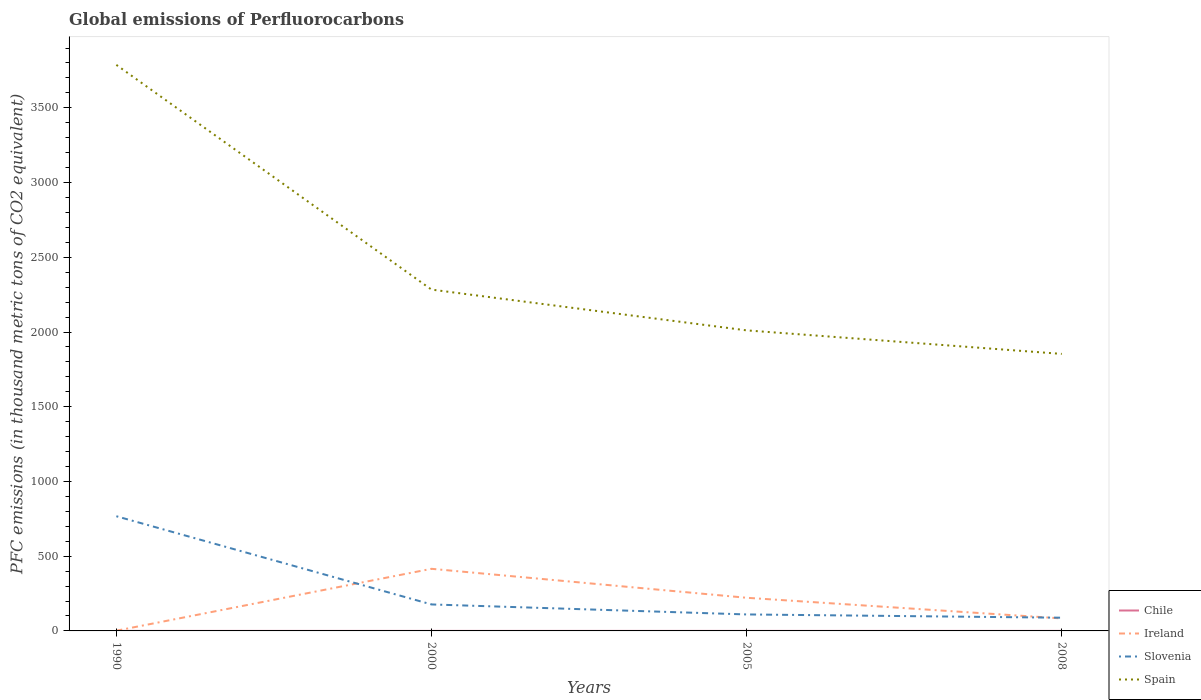How many different coloured lines are there?
Provide a succinct answer. 4. Across all years, what is the maximum global emissions of Perfluorocarbons in Ireland?
Ensure brevity in your answer.  1.4. What is the total global emissions of Perfluorocarbons in Slovenia in the graph?
Offer a terse response. 679. What is the difference between the highest and the second highest global emissions of Perfluorocarbons in Ireland?
Offer a very short reply. 414.2. What is the difference between the highest and the lowest global emissions of Perfluorocarbons in Ireland?
Provide a short and direct response. 2. Is the global emissions of Perfluorocarbons in Ireland strictly greater than the global emissions of Perfluorocarbons in Chile over the years?
Ensure brevity in your answer.  No. Are the values on the major ticks of Y-axis written in scientific E-notation?
Ensure brevity in your answer.  No. Does the graph contain any zero values?
Provide a succinct answer. No. Does the graph contain grids?
Provide a succinct answer. No. Where does the legend appear in the graph?
Your answer should be compact. Bottom right. What is the title of the graph?
Offer a very short reply. Global emissions of Perfluorocarbons. What is the label or title of the Y-axis?
Ensure brevity in your answer.  PFC emissions (in thousand metric tons of CO2 equivalent). What is the PFC emissions (in thousand metric tons of CO2 equivalent) in Slovenia in 1990?
Your answer should be compact. 767.4. What is the PFC emissions (in thousand metric tons of CO2 equivalent) of Spain in 1990?
Provide a short and direct response. 3787.4. What is the PFC emissions (in thousand metric tons of CO2 equivalent) in Chile in 2000?
Offer a terse response. 0.2. What is the PFC emissions (in thousand metric tons of CO2 equivalent) in Ireland in 2000?
Your response must be concise. 415.6. What is the PFC emissions (in thousand metric tons of CO2 equivalent) of Slovenia in 2000?
Make the answer very short. 177.2. What is the PFC emissions (in thousand metric tons of CO2 equivalent) of Spain in 2000?
Ensure brevity in your answer.  2283.8. What is the PFC emissions (in thousand metric tons of CO2 equivalent) in Ireland in 2005?
Offer a terse response. 221.8. What is the PFC emissions (in thousand metric tons of CO2 equivalent) in Slovenia in 2005?
Keep it short and to the point. 110.3. What is the PFC emissions (in thousand metric tons of CO2 equivalent) in Spain in 2005?
Your answer should be very brief. 2011. What is the PFC emissions (in thousand metric tons of CO2 equivalent) of Chile in 2008?
Provide a succinct answer. 0.2. What is the PFC emissions (in thousand metric tons of CO2 equivalent) in Ireland in 2008?
Your response must be concise. 83.6. What is the PFC emissions (in thousand metric tons of CO2 equivalent) in Slovenia in 2008?
Make the answer very short. 88.4. What is the PFC emissions (in thousand metric tons of CO2 equivalent) in Spain in 2008?
Your answer should be compact. 1853.5. Across all years, what is the maximum PFC emissions (in thousand metric tons of CO2 equivalent) of Ireland?
Make the answer very short. 415.6. Across all years, what is the maximum PFC emissions (in thousand metric tons of CO2 equivalent) of Slovenia?
Your answer should be very brief. 767.4. Across all years, what is the maximum PFC emissions (in thousand metric tons of CO2 equivalent) in Spain?
Provide a short and direct response. 3787.4. Across all years, what is the minimum PFC emissions (in thousand metric tons of CO2 equivalent) of Chile?
Your answer should be very brief. 0.2. Across all years, what is the minimum PFC emissions (in thousand metric tons of CO2 equivalent) in Slovenia?
Make the answer very short. 88.4. Across all years, what is the minimum PFC emissions (in thousand metric tons of CO2 equivalent) in Spain?
Offer a very short reply. 1853.5. What is the total PFC emissions (in thousand metric tons of CO2 equivalent) of Ireland in the graph?
Ensure brevity in your answer.  722.4. What is the total PFC emissions (in thousand metric tons of CO2 equivalent) of Slovenia in the graph?
Make the answer very short. 1143.3. What is the total PFC emissions (in thousand metric tons of CO2 equivalent) in Spain in the graph?
Make the answer very short. 9935.7. What is the difference between the PFC emissions (in thousand metric tons of CO2 equivalent) of Chile in 1990 and that in 2000?
Ensure brevity in your answer.  0. What is the difference between the PFC emissions (in thousand metric tons of CO2 equivalent) in Ireland in 1990 and that in 2000?
Offer a very short reply. -414.2. What is the difference between the PFC emissions (in thousand metric tons of CO2 equivalent) in Slovenia in 1990 and that in 2000?
Your answer should be very brief. 590.2. What is the difference between the PFC emissions (in thousand metric tons of CO2 equivalent) of Spain in 1990 and that in 2000?
Offer a terse response. 1503.6. What is the difference between the PFC emissions (in thousand metric tons of CO2 equivalent) of Ireland in 1990 and that in 2005?
Give a very brief answer. -220.4. What is the difference between the PFC emissions (in thousand metric tons of CO2 equivalent) of Slovenia in 1990 and that in 2005?
Make the answer very short. 657.1. What is the difference between the PFC emissions (in thousand metric tons of CO2 equivalent) of Spain in 1990 and that in 2005?
Offer a terse response. 1776.4. What is the difference between the PFC emissions (in thousand metric tons of CO2 equivalent) in Chile in 1990 and that in 2008?
Give a very brief answer. 0. What is the difference between the PFC emissions (in thousand metric tons of CO2 equivalent) of Ireland in 1990 and that in 2008?
Ensure brevity in your answer.  -82.2. What is the difference between the PFC emissions (in thousand metric tons of CO2 equivalent) of Slovenia in 1990 and that in 2008?
Keep it short and to the point. 679. What is the difference between the PFC emissions (in thousand metric tons of CO2 equivalent) of Spain in 1990 and that in 2008?
Your answer should be very brief. 1933.9. What is the difference between the PFC emissions (in thousand metric tons of CO2 equivalent) of Ireland in 2000 and that in 2005?
Offer a very short reply. 193.8. What is the difference between the PFC emissions (in thousand metric tons of CO2 equivalent) of Slovenia in 2000 and that in 2005?
Offer a very short reply. 66.9. What is the difference between the PFC emissions (in thousand metric tons of CO2 equivalent) in Spain in 2000 and that in 2005?
Provide a short and direct response. 272.8. What is the difference between the PFC emissions (in thousand metric tons of CO2 equivalent) in Ireland in 2000 and that in 2008?
Offer a very short reply. 332. What is the difference between the PFC emissions (in thousand metric tons of CO2 equivalent) of Slovenia in 2000 and that in 2008?
Provide a succinct answer. 88.8. What is the difference between the PFC emissions (in thousand metric tons of CO2 equivalent) of Spain in 2000 and that in 2008?
Your answer should be very brief. 430.3. What is the difference between the PFC emissions (in thousand metric tons of CO2 equivalent) in Chile in 2005 and that in 2008?
Keep it short and to the point. 0. What is the difference between the PFC emissions (in thousand metric tons of CO2 equivalent) in Ireland in 2005 and that in 2008?
Keep it short and to the point. 138.2. What is the difference between the PFC emissions (in thousand metric tons of CO2 equivalent) of Slovenia in 2005 and that in 2008?
Keep it short and to the point. 21.9. What is the difference between the PFC emissions (in thousand metric tons of CO2 equivalent) in Spain in 2005 and that in 2008?
Offer a very short reply. 157.5. What is the difference between the PFC emissions (in thousand metric tons of CO2 equivalent) of Chile in 1990 and the PFC emissions (in thousand metric tons of CO2 equivalent) of Ireland in 2000?
Make the answer very short. -415.4. What is the difference between the PFC emissions (in thousand metric tons of CO2 equivalent) in Chile in 1990 and the PFC emissions (in thousand metric tons of CO2 equivalent) in Slovenia in 2000?
Provide a short and direct response. -177. What is the difference between the PFC emissions (in thousand metric tons of CO2 equivalent) in Chile in 1990 and the PFC emissions (in thousand metric tons of CO2 equivalent) in Spain in 2000?
Keep it short and to the point. -2283.6. What is the difference between the PFC emissions (in thousand metric tons of CO2 equivalent) of Ireland in 1990 and the PFC emissions (in thousand metric tons of CO2 equivalent) of Slovenia in 2000?
Offer a very short reply. -175.8. What is the difference between the PFC emissions (in thousand metric tons of CO2 equivalent) in Ireland in 1990 and the PFC emissions (in thousand metric tons of CO2 equivalent) in Spain in 2000?
Keep it short and to the point. -2282.4. What is the difference between the PFC emissions (in thousand metric tons of CO2 equivalent) in Slovenia in 1990 and the PFC emissions (in thousand metric tons of CO2 equivalent) in Spain in 2000?
Provide a succinct answer. -1516.4. What is the difference between the PFC emissions (in thousand metric tons of CO2 equivalent) in Chile in 1990 and the PFC emissions (in thousand metric tons of CO2 equivalent) in Ireland in 2005?
Provide a succinct answer. -221.6. What is the difference between the PFC emissions (in thousand metric tons of CO2 equivalent) of Chile in 1990 and the PFC emissions (in thousand metric tons of CO2 equivalent) of Slovenia in 2005?
Ensure brevity in your answer.  -110.1. What is the difference between the PFC emissions (in thousand metric tons of CO2 equivalent) in Chile in 1990 and the PFC emissions (in thousand metric tons of CO2 equivalent) in Spain in 2005?
Give a very brief answer. -2010.8. What is the difference between the PFC emissions (in thousand metric tons of CO2 equivalent) of Ireland in 1990 and the PFC emissions (in thousand metric tons of CO2 equivalent) of Slovenia in 2005?
Make the answer very short. -108.9. What is the difference between the PFC emissions (in thousand metric tons of CO2 equivalent) in Ireland in 1990 and the PFC emissions (in thousand metric tons of CO2 equivalent) in Spain in 2005?
Keep it short and to the point. -2009.6. What is the difference between the PFC emissions (in thousand metric tons of CO2 equivalent) of Slovenia in 1990 and the PFC emissions (in thousand metric tons of CO2 equivalent) of Spain in 2005?
Your answer should be compact. -1243.6. What is the difference between the PFC emissions (in thousand metric tons of CO2 equivalent) in Chile in 1990 and the PFC emissions (in thousand metric tons of CO2 equivalent) in Ireland in 2008?
Make the answer very short. -83.4. What is the difference between the PFC emissions (in thousand metric tons of CO2 equivalent) of Chile in 1990 and the PFC emissions (in thousand metric tons of CO2 equivalent) of Slovenia in 2008?
Offer a terse response. -88.2. What is the difference between the PFC emissions (in thousand metric tons of CO2 equivalent) of Chile in 1990 and the PFC emissions (in thousand metric tons of CO2 equivalent) of Spain in 2008?
Your answer should be very brief. -1853.3. What is the difference between the PFC emissions (in thousand metric tons of CO2 equivalent) in Ireland in 1990 and the PFC emissions (in thousand metric tons of CO2 equivalent) in Slovenia in 2008?
Your answer should be compact. -87. What is the difference between the PFC emissions (in thousand metric tons of CO2 equivalent) of Ireland in 1990 and the PFC emissions (in thousand metric tons of CO2 equivalent) of Spain in 2008?
Ensure brevity in your answer.  -1852.1. What is the difference between the PFC emissions (in thousand metric tons of CO2 equivalent) of Slovenia in 1990 and the PFC emissions (in thousand metric tons of CO2 equivalent) of Spain in 2008?
Keep it short and to the point. -1086.1. What is the difference between the PFC emissions (in thousand metric tons of CO2 equivalent) of Chile in 2000 and the PFC emissions (in thousand metric tons of CO2 equivalent) of Ireland in 2005?
Your answer should be very brief. -221.6. What is the difference between the PFC emissions (in thousand metric tons of CO2 equivalent) of Chile in 2000 and the PFC emissions (in thousand metric tons of CO2 equivalent) of Slovenia in 2005?
Provide a short and direct response. -110.1. What is the difference between the PFC emissions (in thousand metric tons of CO2 equivalent) in Chile in 2000 and the PFC emissions (in thousand metric tons of CO2 equivalent) in Spain in 2005?
Your answer should be very brief. -2010.8. What is the difference between the PFC emissions (in thousand metric tons of CO2 equivalent) in Ireland in 2000 and the PFC emissions (in thousand metric tons of CO2 equivalent) in Slovenia in 2005?
Offer a very short reply. 305.3. What is the difference between the PFC emissions (in thousand metric tons of CO2 equivalent) of Ireland in 2000 and the PFC emissions (in thousand metric tons of CO2 equivalent) of Spain in 2005?
Make the answer very short. -1595.4. What is the difference between the PFC emissions (in thousand metric tons of CO2 equivalent) of Slovenia in 2000 and the PFC emissions (in thousand metric tons of CO2 equivalent) of Spain in 2005?
Your response must be concise. -1833.8. What is the difference between the PFC emissions (in thousand metric tons of CO2 equivalent) of Chile in 2000 and the PFC emissions (in thousand metric tons of CO2 equivalent) of Ireland in 2008?
Your response must be concise. -83.4. What is the difference between the PFC emissions (in thousand metric tons of CO2 equivalent) of Chile in 2000 and the PFC emissions (in thousand metric tons of CO2 equivalent) of Slovenia in 2008?
Your response must be concise. -88.2. What is the difference between the PFC emissions (in thousand metric tons of CO2 equivalent) in Chile in 2000 and the PFC emissions (in thousand metric tons of CO2 equivalent) in Spain in 2008?
Ensure brevity in your answer.  -1853.3. What is the difference between the PFC emissions (in thousand metric tons of CO2 equivalent) of Ireland in 2000 and the PFC emissions (in thousand metric tons of CO2 equivalent) of Slovenia in 2008?
Your answer should be very brief. 327.2. What is the difference between the PFC emissions (in thousand metric tons of CO2 equivalent) in Ireland in 2000 and the PFC emissions (in thousand metric tons of CO2 equivalent) in Spain in 2008?
Keep it short and to the point. -1437.9. What is the difference between the PFC emissions (in thousand metric tons of CO2 equivalent) in Slovenia in 2000 and the PFC emissions (in thousand metric tons of CO2 equivalent) in Spain in 2008?
Offer a terse response. -1676.3. What is the difference between the PFC emissions (in thousand metric tons of CO2 equivalent) of Chile in 2005 and the PFC emissions (in thousand metric tons of CO2 equivalent) of Ireland in 2008?
Your response must be concise. -83.4. What is the difference between the PFC emissions (in thousand metric tons of CO2 equivalent) of Chile in 2005 and the PFC emissions (in thousand metric tons of CO2 equivalent) of Slovenia in 2008?
Provide a succinct answer. -88.2. What is the difference between the PFC emissions (in thousand metric tons of CO2 equivalent) in Chile in 2005 and the PFC emissions (in thousand metric tons of CO2 equivalent) in Spain in 2008?
Make the answer very short. -1853.3. What is the difference between the PFC emissions (in thousand metric tons of CO2 equivalent) of Ireland in 2005 and the PFC emissions (in thousand metric tons of CO2 equivalent) of Slovenia in 2008?
Your response must be concise. 133.4. What is the difference between the PFC emissions (in thousand metric tons of CO2 equivalent) of Ireland in 2005 and the PFC emissions (in thousand metric tons of CO2 equivalent) of Spain in 2008?
Your answer should be compact. -1631.7. What is the difference between the PFC emissions (in thousand metric tons of CO2 equivalent) in Slovenia in 2005 and the PFC emissions (in thousand metric tons of CO2 equivalent) in Spain in 2008?
Provide a short and direct response. -1743.2. What is the average PFC emissions (in thousand metric tons of CO2 equivalent) in Ireland per year?
Make the answer very short. 180.6. What is the average PFC emissions (in thousand metric tons of CO2 equivalent) of Slovenia per year?
Provide a succinct answer. 285.82. What is the average PFC emissions (in thousand metric tons of CO2 equivalent) in Spain per year?
Your answer should be very brief. 2483.93. In the year 1990, what is the difference between the PFC emissions (in thousand metric tons of CO2 equivalent) of Chile and PFC emissions (in thousand metric tons of CO2 equivalent) of Ireland?
Make the answer very short. -1.2. In the year 1990, what is the difference between the PFC emissions (in thousand metric tons of CO2 equivalent) in Chile and PFC emissions (in thousand metric tons of CO2 equivalent) in Slovenia?
Give a very brief answer. -767.2. In the year 1990, what is the difference between the PFC emissions (in thousand metric tons of CO2 equivalent) of Chile and PFC emissions (in thousand metric tons of CO2 equivalent) of Spain?
Provide a short and direct response. -3787.2. In the year 1990, what is the difference between the PFC emissions (in thousand metric tons of CO2 equivalent) in Ireland and PFC emissions (in thousand metric tons of CO2 equivalent) in Slovenia?
Ensure brevity in your answer.  -766. In the year 1990, what is the difference between the PFC emissions (in thousand metric tons of CO2 equivalent) of Ireland and PFC emissions (in thousand metric tons of CO2 equivalent) of Spain?
Offer a very short reply. -3786. In the year 1990, what is the difference between the PFC emissions (in thousand metric tons of CO2 equivalent) in Slovenia and PFC emissions (in thousand metric tons of CO2 equivalent) in Spain?
Your answer should be compact. -3020. In the year 2000, what is the difference between the PFC emissions (in thousand metric tons of CO2 equivalent) of Chile and PFC emissions (in thousand metric tons of CO2 equivalent) of Ireland?
Offer a very short reply. -415.4. In the year 2000, what is the difference between the PFC emissions (in thousand metric tons of CO2 equivalent) of Chile and PFC emissions (in thousand metric tons of CO2 equivalent) of Slovenia?
Provide a short and direct response. -177. In the year 2000, what is the difference between the PFC emissions (in thousand metric tons of CO2 equivalent) of Chile and PFC emissions (in thousand metric tons of CO2 equivalent) of Spain?
Give a very brief answer. -2283.6. In the year 2000, what is the difference between the PFC emissions (in thousand metric tons of CO2 equivalent) in Ireland and PFC emissions (in thousand metric tons of CO2 equivalent) in Slovenia?
Offer a terse response. 238.4. In the year 2000, what is the difference between the PFC emissions (in thousand metric tons of CO2 equivalent) of Ireland and PFC emissions (in thousand metric tons of CO2 equivalent) of Spain?
Provide a succinct answer. -1868.2. In the year 2000, what is the difference between the PFC emissions (in thousand metric tons of CO2 equivalent) of Slovenia and PFC emissions (in thousand metric tons of CO2 equivalent) of Spain?
Your response must be concise. -2106.6. In the year 2005, what is the difference between the PFC emissions (in thousand metric tons of CO2 equivalent) in Chile and PFC emissions (in thousand metric tons of CO2 equivalent) in Ireland?
Keep it short and to the point. -221.6. In the year 2005, what is the difference between the PFC emissions (in thousand metric tons of CO2 equivalent) in Chile and PFC emissions (in thousand metric tons of CO2 equivalent) in Slovenia?
Provide a short and direct response. -110.1. In the year 2005, what is the difference between the PFC emissions (in thousand metric tons of CO2 equivalent) in Chile and PFC emissions (in thousand metric tons of CO2 equivalent) in Spain?
Ensure brevity in your answer.  -2010.8. In the year 2005, what is the difference between the PFC emissions (in thousand metric tons of CO2 equivalent) in Ireland and PFC emissions (in thousand metric tons of CO2 equivalent) in Slovenia?
Provide a succinct answer. 111.5. In the year 2005, what is the difference between the PFC emissions (in thousand metric tons of CO2 equivalent) of Ireland and PFC emissions (in thousand metric tons of CO2 equivalent) of Spain?
Provide a short and direct response. -1789.2. In the year 2005, what is the difference between the PFC emissions (in thousand metric tons of CO2 equivalent) in Slovenia and PFC emissions (in thousand metric tons of CO2 equivalent) in Spain?
Keep it short and to the point. -1900.7. In the year 2008, what is the difference between the PFC emissions (in thousand metric tons of CO2 equivalent) of Chile and PFC emissions (in thousand metric tons of CO2 equivalent) of Ireland?
Your answer should be compact. -83.4. In the year 2008, what is the difference between the PFC emissions (in thousand metric tons of CO2 equivalent) in Chile and PFC emissions (in thousand metric tons of CO2 equivalent) in Slovenia?
Your answer should be compact. -88.2. In the year 2008, what is the difference between the PFC emissions (in thousand metric tons of CO2 equivalent) in Chile and PFC emissions (in thousand metric tons of CO2 equivalent) in Spain?
Keep it short and to the point. -1853.3. In the year 2008, what is the difference between the PFC emissions (in thousand metric tons of CO2 equivalent) of Ireland and PFC emissions (in thousand metric tons of CO2 equivalent) of Slovenia?
Provide a succinct answer. -4.8. In the year 2008, what is the difference between the PFC emissions (in thousand metric tons of CO2 equivalent) in Ireland and PFC emissions (in thousand metric tons of CO2 equivalent) in Spain?
Offer a terse response. -1769.9. In the year 2008, what is the difference between the PFC emissions (in thousand metric tons of CO2 equivalent) in Slovenia and PFC emissions (in thousand metric tons of CO2 equivalent) in Spain?
Give a very brief answer. -1765.1. What is the ratio of the PFC emissions (in thousand metric tons of CO2 equivalent) of Chile in 1990 to that in 2000?
Provide a succinct answer. 1. What is the ratio of the PFC emissions (in thousand metric tons of CO2 equivalent) in Ireland in 1990 to that in 2000?
Make the answer very short. 0. What is the ratio of the PFC emissions (in thousand metric tons of CO2 equivalent) in Slovenia in 1990 to that in 2000?
Your answer should be very brief. 4.33. What is the ratio of the PFC emissions (in thousand metric tons of CO2 equivalent) of Spain in 1990 to that in 2000?
Your answer should be very brief. 1.66. What is the ratio of the PFC emissions (in thousand metric tons of CO2 equivalent) in Chile in 1990 to that in 2005?
Your answer should be compact. 1. What is the ratio of the PFC emissions (in thousand metric tons of CO2 equivalent) of Ireland in 1990 to that in 2005?
Make the answer very short. 0.01. What is the ratio of the PFC emissions (in thousand metric tons of CO2 equivalent) of Slovenia in 1990 to that in 2005?
Your answer should be compact. 6.96. What is the ratio of the PFC emissions (in thousand metric tons of CO2 equivalent) of Spain in 1990 to that in 2005?
Make the answer very short. 1.88. What is the ratio of the PFC emissions (in thousand metric tons of CO2 equivalent) of Chile in 1990 to that in 2008?
Offer a terse response. 1. What is the ratio of the PFC emissions (in thousand metric tons of CO2 equivalent) in Ireland in 1990 to that in 2008?
Ensure brevity in your answer.  0.02. What is the ratio of the PFC emissions (in thousand metric tons of CO2 equivalent) of Slovenia in 1990 to that in 2008?
Provide a short and direct response. 8.68. What is the ratio of the PFC emissions (in thousand metric tons of CO2 equivalent) in Spain in 1990 to that in 2008?
Make the answer very short. 2.04. What is the ratio of the PFC emissions (in thousand metric tons of CO2 equivalent) of Ireland in 2000 to that in 2005?
Your answer should be very brief. 1.87. What is the ratio of the PFC emissions (in thousand metric tons of CO2 equivalent) in Slovenia in 2000 to that in 2005?
Make the answer very short. 1.61. What is the ratio of the PFC emissions (in thousand metric tons of CO2 equivalent) in Spain in 2000 to that in 2005?
Keep it short and to the point. 1.14. What is the ratio of the PFC emissions (in thousand metric tons of CO2 equivalent) in Chile in 2000 to that in 2008?
Your response must be concise. 1. What is the ratio of the PFC emissions (in thousand metric tons of CO2 equivalent) in Ireland in 2000 to that in 2008?
Offer a very short reply. 4.97. What is the ratio of the PFC emissions (in thousand metric tons of CO2 equivalent) of Slovenia in 2000 to that in 2008?
Provide a succinct answer. 2. What is the ratio of the PFC emissions (in thousand metric tons of CO2 equivalent) in Spain in 2000 to that in 2008?
Offer a terse response. 1.23. What is the ratio of the PFC emissions (in thousand metric tons of CO2 equivalent) in Ireland in 2005 to that in 2008?
Make the answer very short. 2.65. What is the ratio of the PFC emissions (in thousand metric tons of CO2 equivalent) of Slovenia in 2005 to that in 2008?
Your answer should be very brief. 1.25. What is the ratio of the PFC emissions (in thousand metric tons of CO2 equivalent) of Spain in 2005 to that in 2008?
Give a very brief answer. 1.08. What is the difference between the highest and the second highest PFC emissions (in thousand metric tons of CO2 equivalent) of Ireland?
Your answer should be compact. 193.8. What is the difference between the highest and the second highest PFC emissions (in thousand metric tons of CO2 equivalent) in Slovenia?
Your response must be concise. 590.2. What is the difference between the highest and the second highest PFC emissions (in thousand metric tons of CO2 equivalent) in Spain?
Provide a short and direct response. 1503.6. What is the difference between the highest and the lowest PFC emissions (in thousand metric tons of CO2 equivalent) of Chile?
Provide a short and direct response. 0. What is the difference between the highest and the lowest PFC emissions (in thousand metric tons of CO2 equivalent) in Ireland?
Your answer should be compact. 414.2. What is the difference between the highest and the lowest PFC emissions (in thousand metric tons of CO2 equivalent) of Slovenia?
Provide a short and direct response. 679. What is the difference between the highest and the lowest PFC emissions (in thousand metric tons of CO2 equivalent) of Spain?
Make the answer very short. 1933.9. 